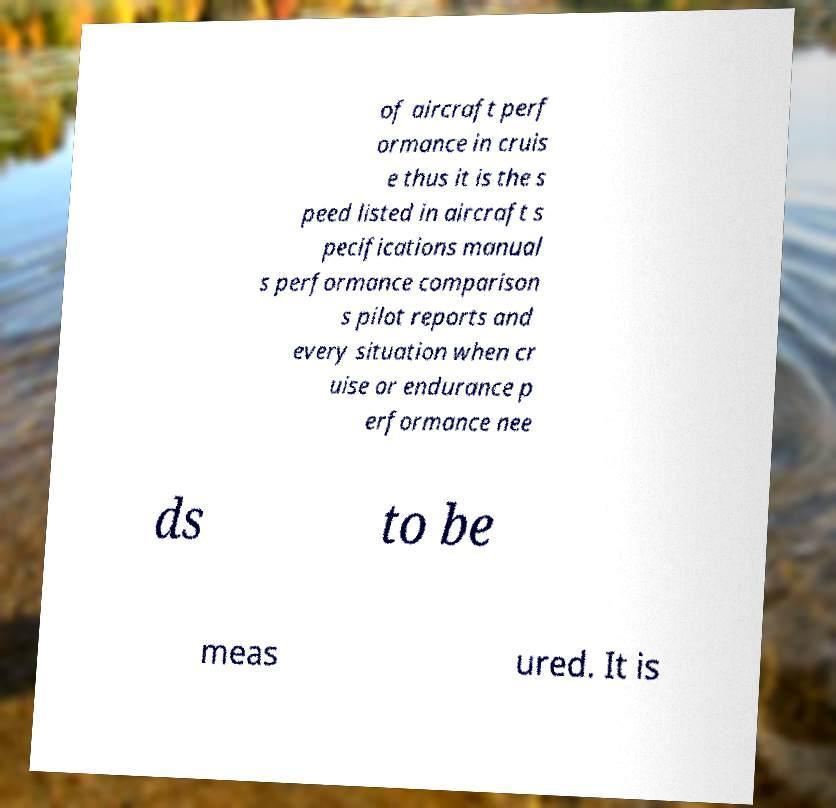For documentation purposes, I need the text within this image transcribed. Could you provide that? of aircraft perf ormance in cruis e thus it is the s peed listed in aircraft s pecifications manual s performance comparison s pilot reports and every situation when cr uise or endurance p erformance nee ds to be meas ured. It is 